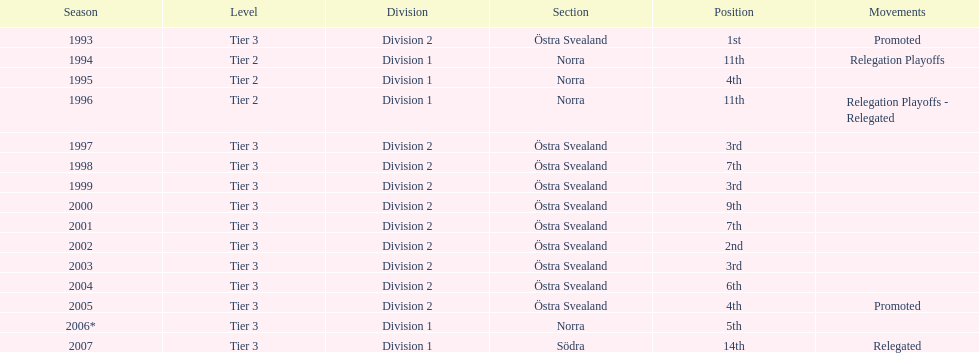What is listed under the movements column of the last season? Relegated. 